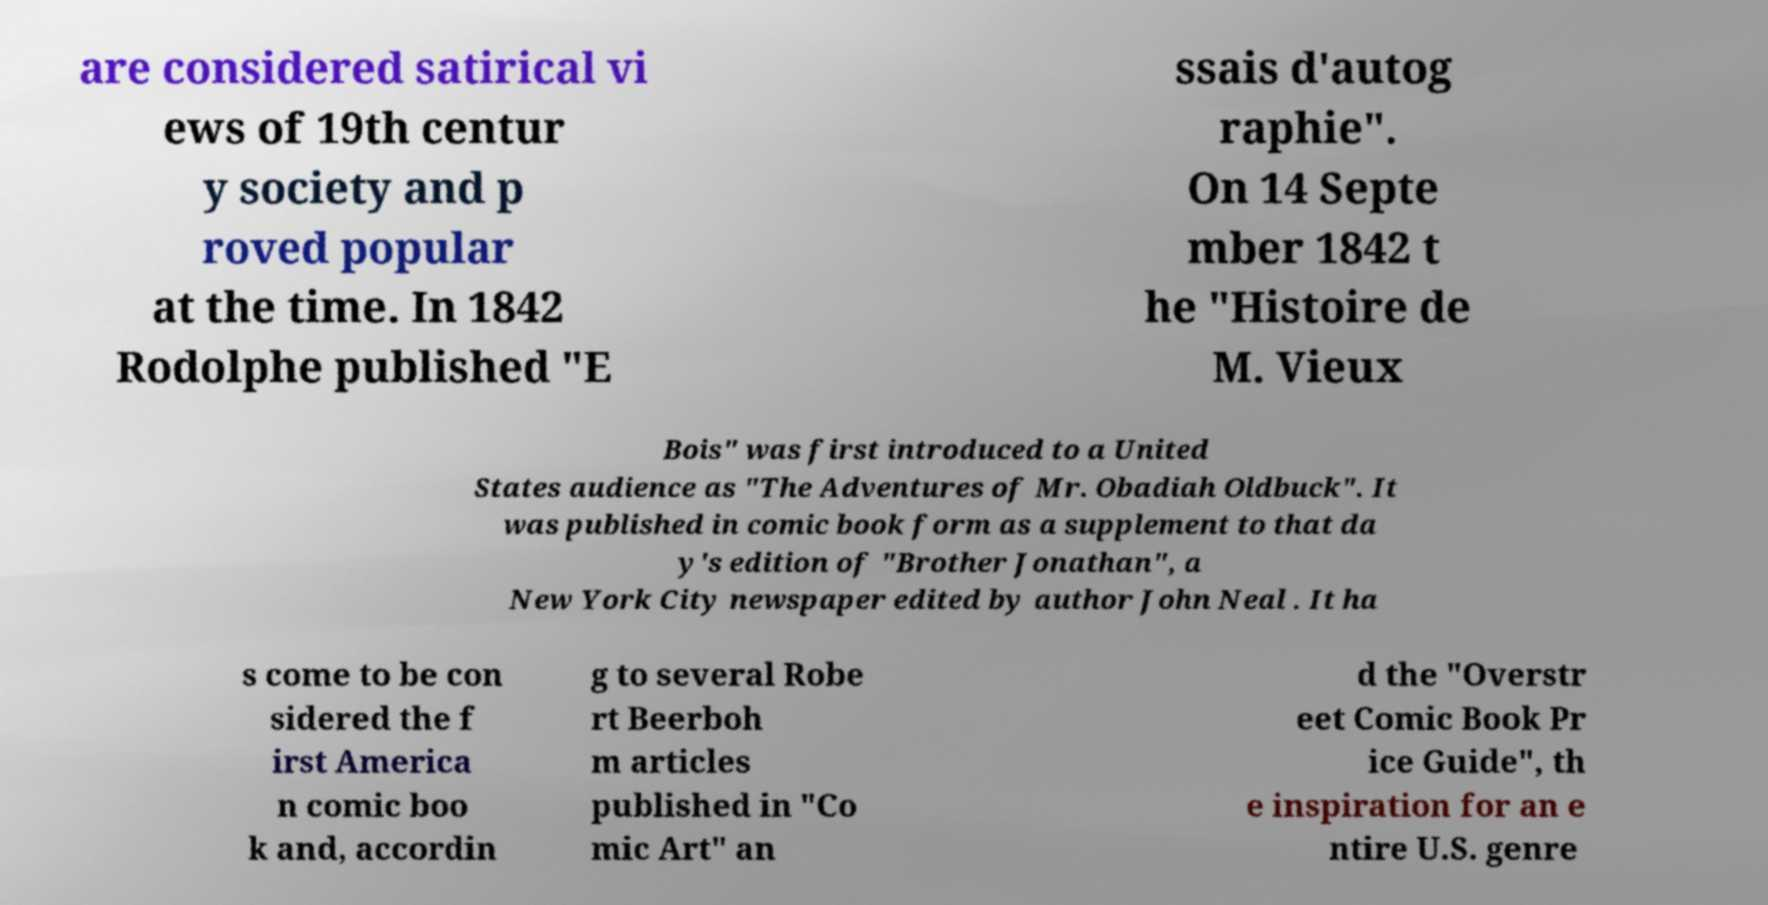For documentation purposes, I need the text within this image transcribed. Could you provide that? are considered satirical vi ews of 19th centur y society and p roved popular at the time. In 1842 Rodolphe published "E ssais d'autog raphie". On 14 Septe mber 1842 t he "Histoire de M. Vieux Bois" was first introduced to a United States audience as "The Adventures of Mr. Obadiah Oldbuck". It was published in comic book form as a supplement to that da y's edition of "Brother Jonathan", a New York City newspaper edited by author John Neal . It ha s come to be con sidered the f irst America n comic boo k and, accordin g to several Robe rt Beerboh m articles published in "Co mic Art" an d the "Overstr eet Comic Book Pr ice Guide", th e inspiration for an e ntire U.S. genre 